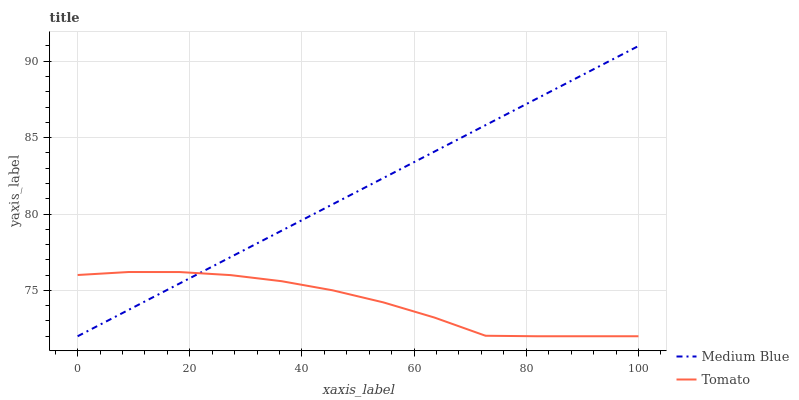Does Medium Blue have the minimum area under the curve?
Answer yes or no. No. Is Medium Blue the roughest?
Answer yes or no. No. 